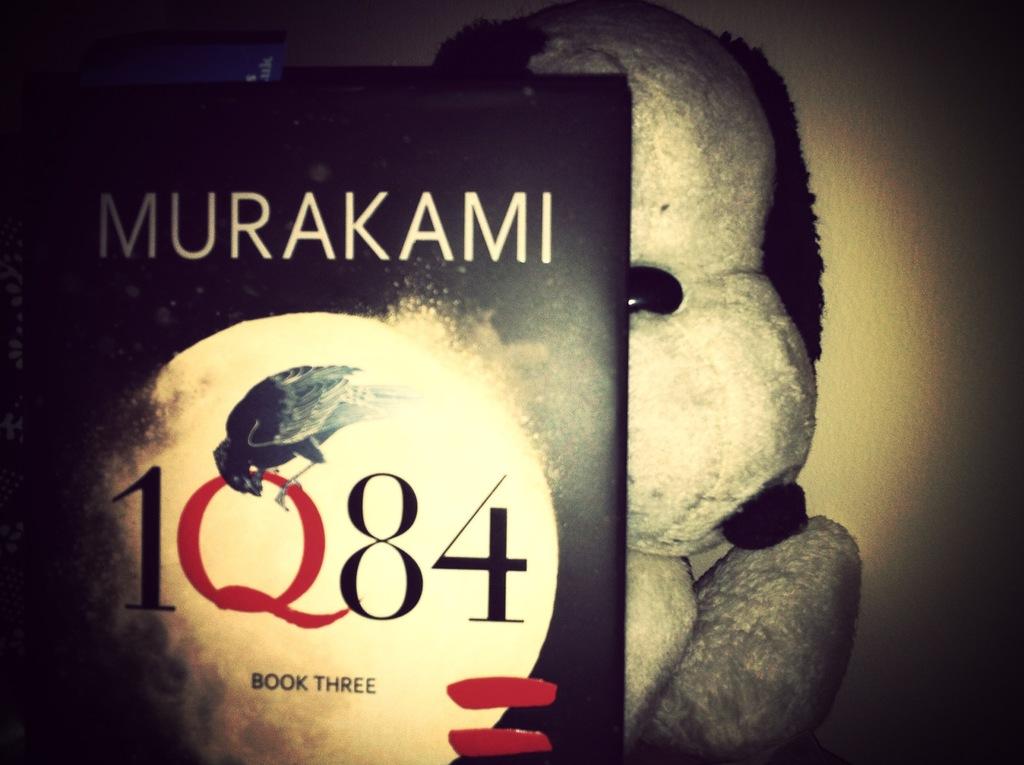What number in the series is the book?
Offer a terse response. Three. Who wrote the book?
Your answer should be compact. Murakami. 